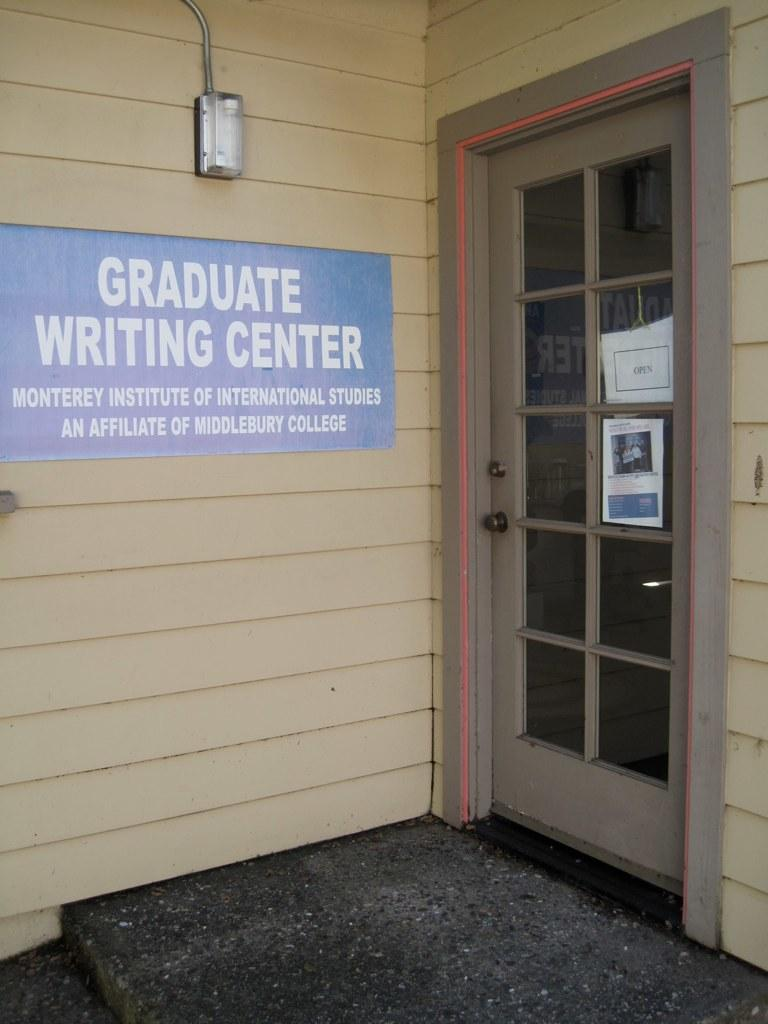What is the color of the board in the image? The board in the image is blue. How is the board attached to the wall? The board is fixed to the wall. What can be found on the board? There is text on the board. What can be seen in the image that provides light? There is a light visible in the image. What type of door is present in the image? There is a glass door in the image. What sense is being used to make a selection on the board in the image? The image does not depict anyone using their senses to make a selection on the board, as it is a static image. 